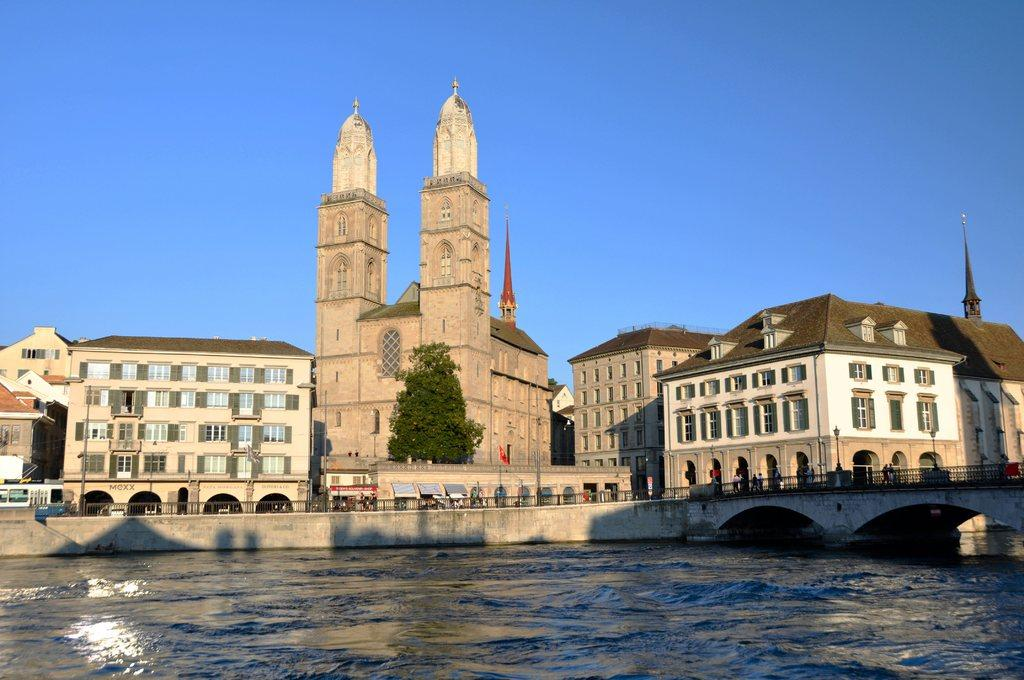What type of natural feature is present in the image? There is a lake in the image. What man-made feature can be seen in the image? There is a road visible in the image. What are the people in the image doing? There are people walking in the image. What can be seen in the background of the image? There are buildings and trees in the background of the image. What type of square is visible in the image? There is no square present in the image. How many snails can be seen crawling on the road in the image? There are no snails visible in the image; only people walking on the road can be seen. 